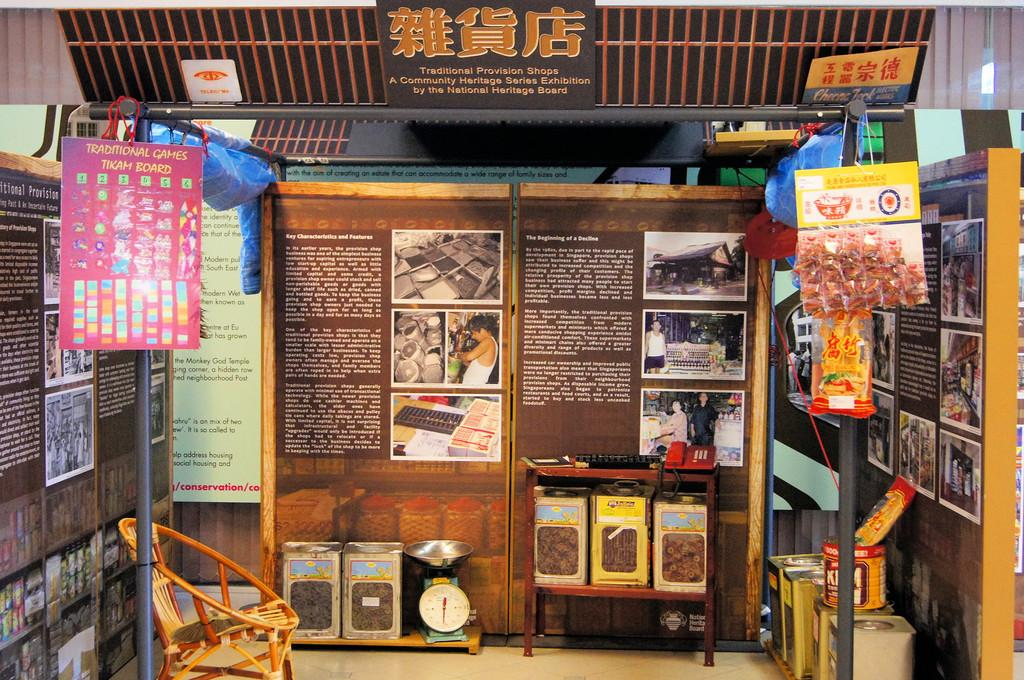<image>
Render a clear and concise summary of the photo. an open area with pictures and labels with one of them that says 'traditional games tikam board' 